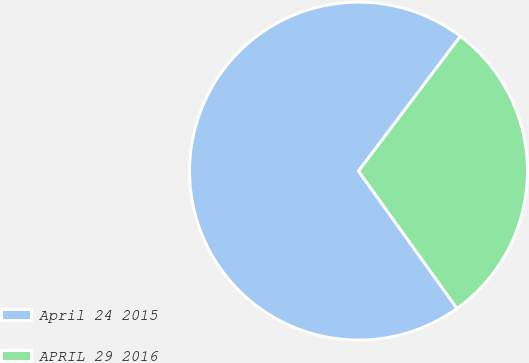Convert chart. <chart><loc_0><loc_0><loc_500><loc_500><pie_chart><fcel>April 24 2015<fcel>APRIL 29 2016<nl><fcel>70.2%<fcel>29.8%<nl></chart> 